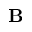<formula> <loc_0><loc_0><loc_500><loc_500>B</formula> 